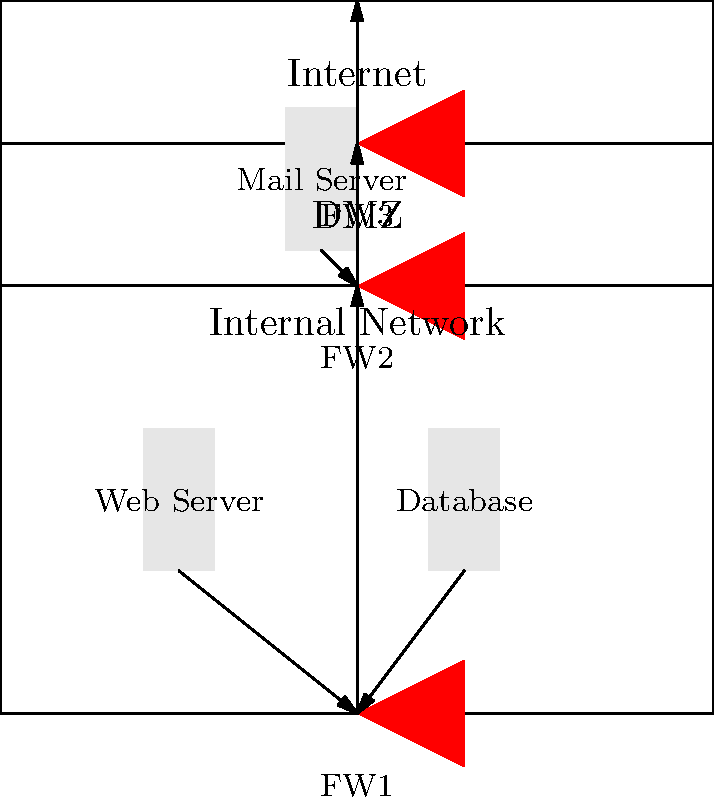Based on the network security architecture diagram, which firewall is responsible for controlling traffic between the internal network and the DMZ, and what potential security risks might arise if this firewall were to fail? To answer this question, let's analyze the diagram step-by-step:

1. The diagram shows a three-tier network architecture:
   - Internal Network (bottom)
   - DMZ (middle)
   - Internet (top)

2. There are three firewalls labeled:
   - FW1: between the Internal Network and DMZ
   - FW2: between the Internal Network and DMZ
   - FW3: between the DMZ and Internet

3. The firewall responsible for controlling traffic between the internal network and the DMZ is FW2.

4. If FW2 were to fail, several security risks could arise:

   a) Unrestricted access: The DMZ, which typically contains publicly accessible services (like the mail server in the diagram), could gain unrestricted access to the internal network.
   
   b) Increased attack surface: Malicious actors who compromise services in the DMZ could more easily pivot to attack internal resources.
   
   c) Data exfiltration: Sensitive data from internal servers (e.g., the database shown) could be more easily exfiltrated through compromised DMZ services.
   
   d) Malware propagation: Malware infections in the DMZ could spread more readily to the internal network.
   
   e) Loss of segmentation: The principle of network segmentation would be compromised, reducing the overall security posture.

5. The presence of FW1 provides some mitigation, as it still controls traffic between the internal network and lower layers. However, its effectiveness depends on its configuration and whether it's designed to handle the failure of FW2.

Understanding this architecture and potential failure modes is crucial for maintaining network security, especially in environments handling sensitive information like those Dr. Basab K. Mookerjee might have worked with.
Answer: FW2; risks include unrestricted access, increased attack surface, data exfiltration, malware propagation, and loss of network segmentation. 